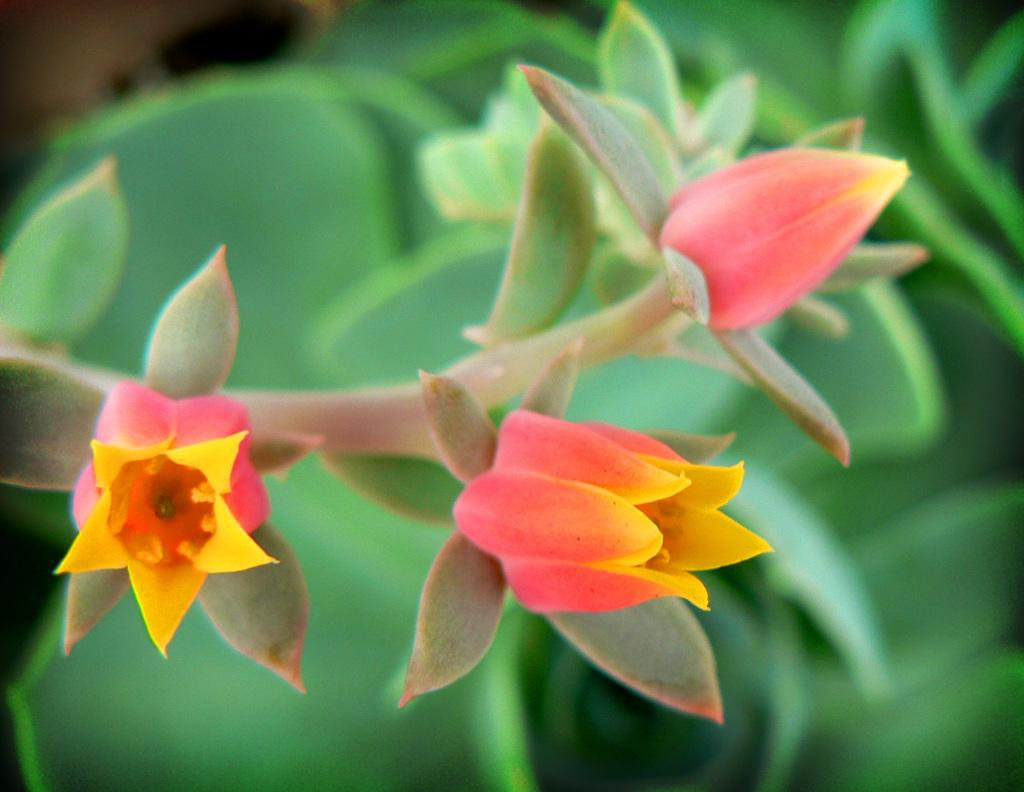What type of plant is visible in the image? The image contains flowers on a plant. Can you describe the background of the image? The background of the image is blurred. What type of skin condition can be seen on the plant in the image? There is no skin condition present on the plant in the image, as plants do not have skin. 